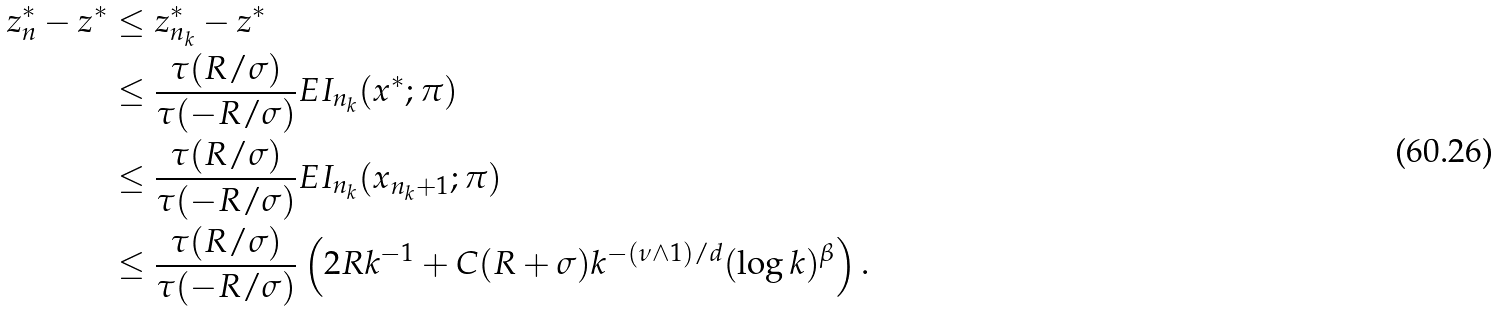Convert formula to latex. <formula><loc_0><loc_0><loc_500><loc_500>z _ { n } ^ { * } - z ^ { * } & \leq z _ { n _ { k } } ^ { * } - z ^ { * } \\ & \leq \frac { \tau ( R / \sigma ) } { \tau ( - R / \sigma ) } E I _ { n _ { k } } ( x ^ { * } ; \pi ) \\ & \leq \frac { \tau ( R / \sigma ) } { \tau ( - R / \sigma ) } E I _ { n _ { k } } ( x _ { n _ { k } + 1 } ; \pi ) \\ & \leq \frac { \tau ( R / \sigma ) } { \tau ( - R / \sigma ) } \left ( 2 R k ^ { - 1 } + C ( R + \sigma ) k ^ { - ( \nu \wedge 1 ) / d } ( \log k ) ^ { \beta } \right ) .</formula> 